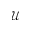<formula> <loc_0><loc_0><loc_500><loc_500>\mathcal { U }</formula> 